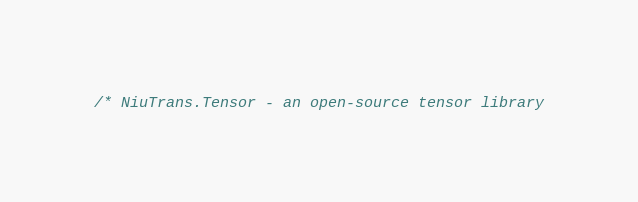Convert code to text. <code><loc_0><loc_0><loc_500><loc_500><_Cuda_>/* NiuTrans.Tensor - an open-source tensor library</code> 